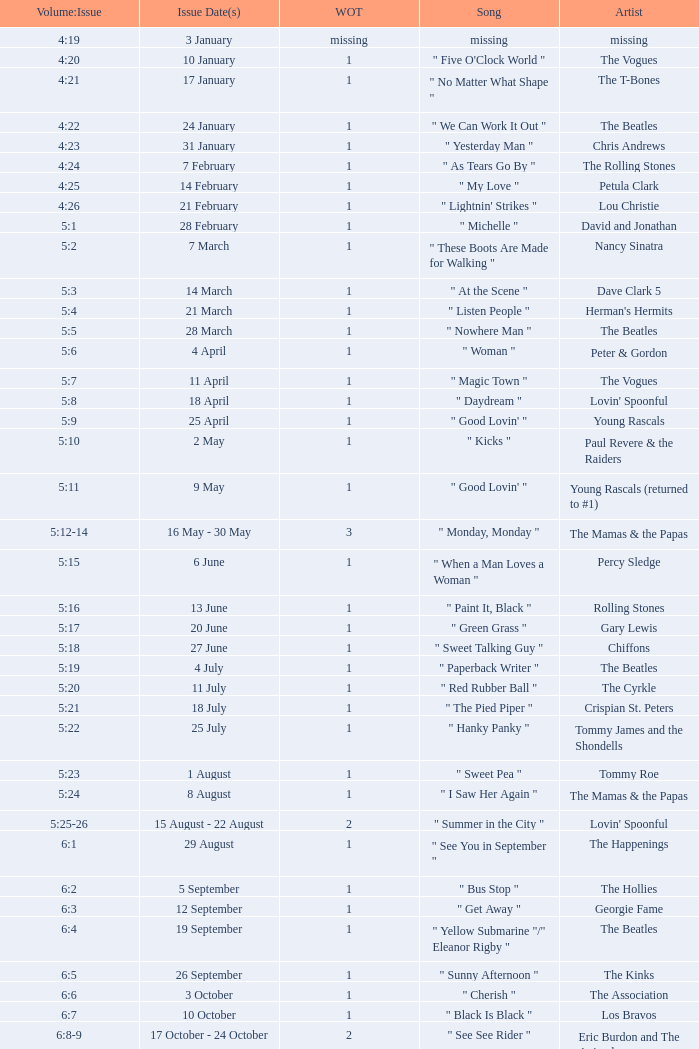An artist of the Beatles with an issue date(s) of 19 September has what as the listed weeks on top? 1.0. 